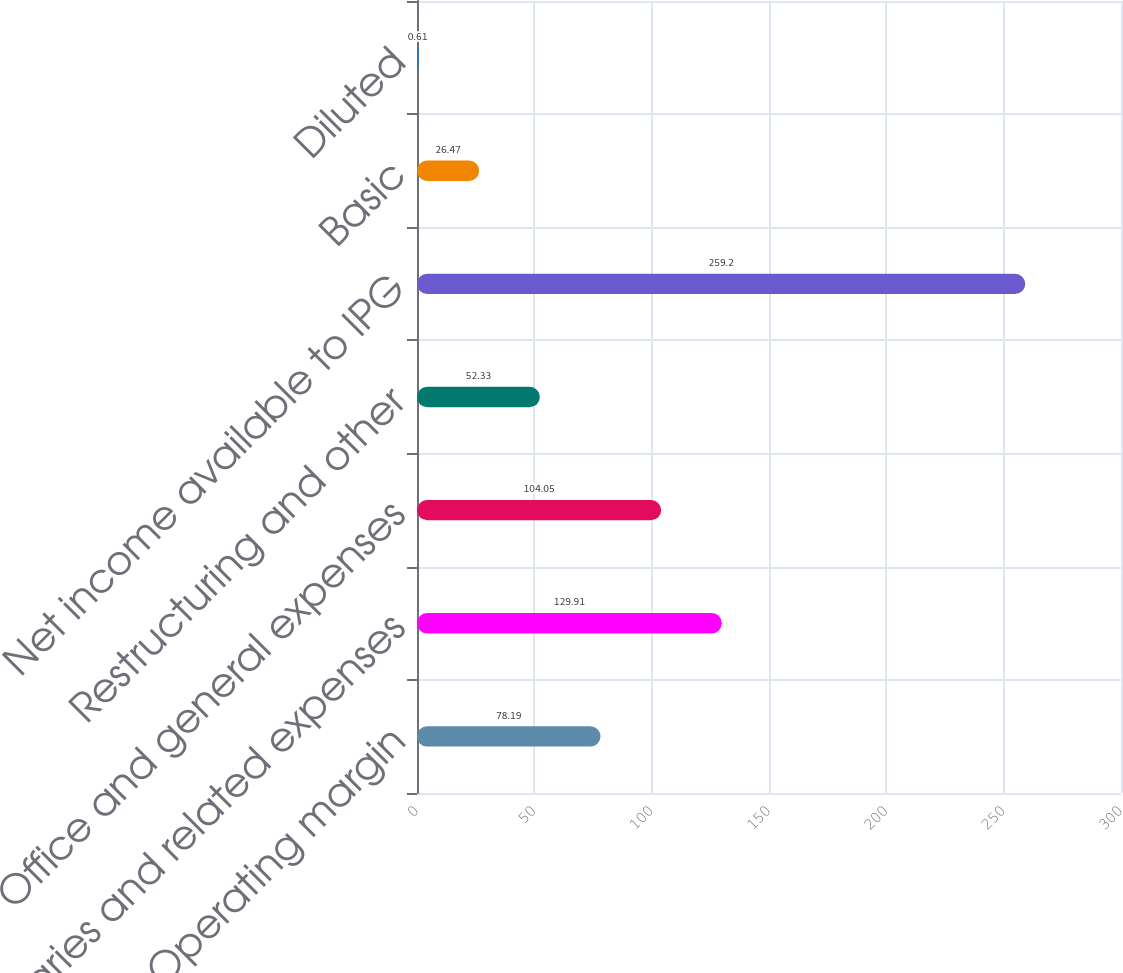Convert chart. <chart><loc_0><loc_0><loc_500><loc_500><bar_chart><fcel>Operating margin<fcel>Salaries and related expenses<fcel>Office and general expenses<fcel>Restructuring and other<fcel>Net income available to IPG<fcel>Basic<fcel>Diluted<nl><fcel>78.19<fcel>129.91<fcel>104.05<fcel>52.33<fcel>259.2<fcel>26.47<fcel>0.61<nl></chart> 